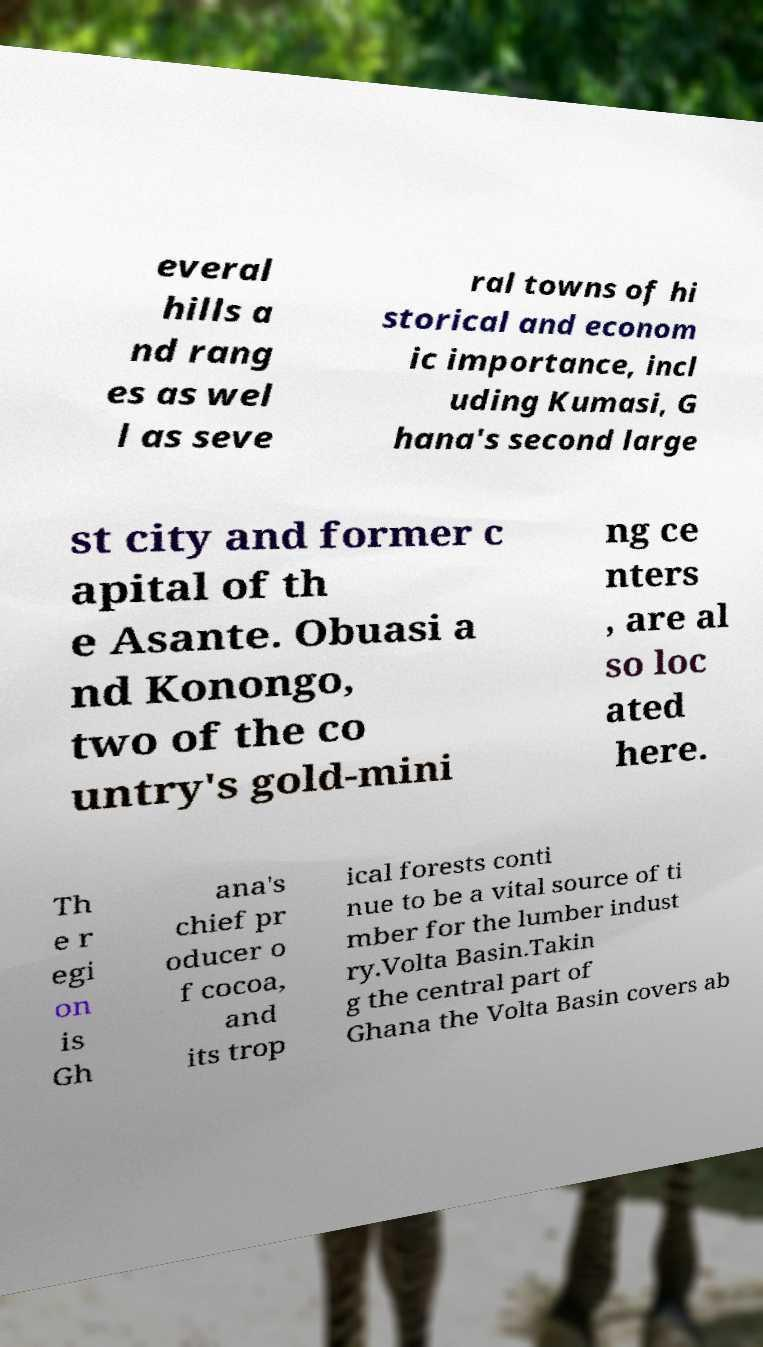What messages or text are displayed in this image? I need them in a readable, typed format. everal hills a nd rang es as wel l as seve ral towns of hi storical and econom ic importance, incl uding Kumasi, G hana's second large st city and former c apital of th e Asante. Obuasi a nd Konongo, two of the co untry's gold-mini ng ce nters , are al so loc ated here. Th e r egi on is Gh ana's chief pr oducer o f cocoa, and its trop ical forests conti nue to be a vital source of ti mber for the lumber indust ry.Volta Basin.Takin g the central part of Ghana the Volta Basin covers ab 